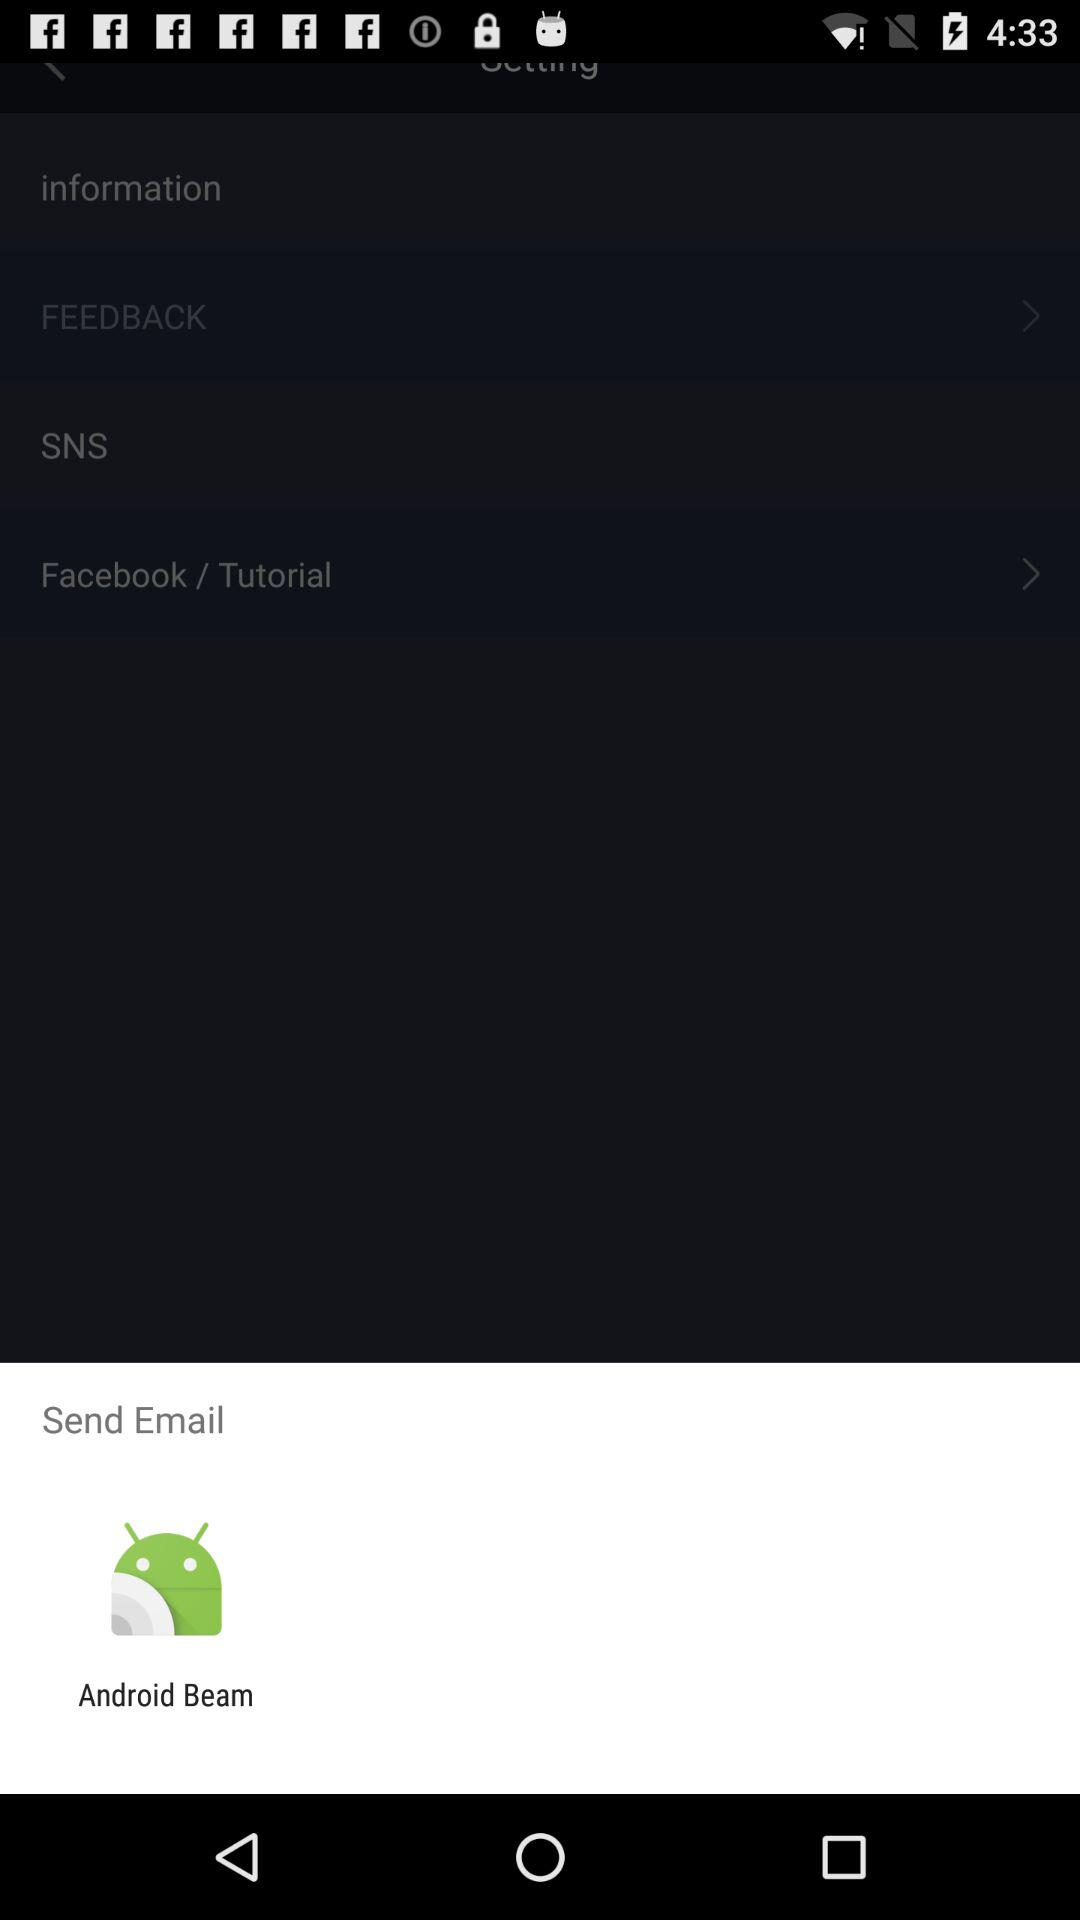Through what option can the email be sent? The email can be sent through "Android Beam". 